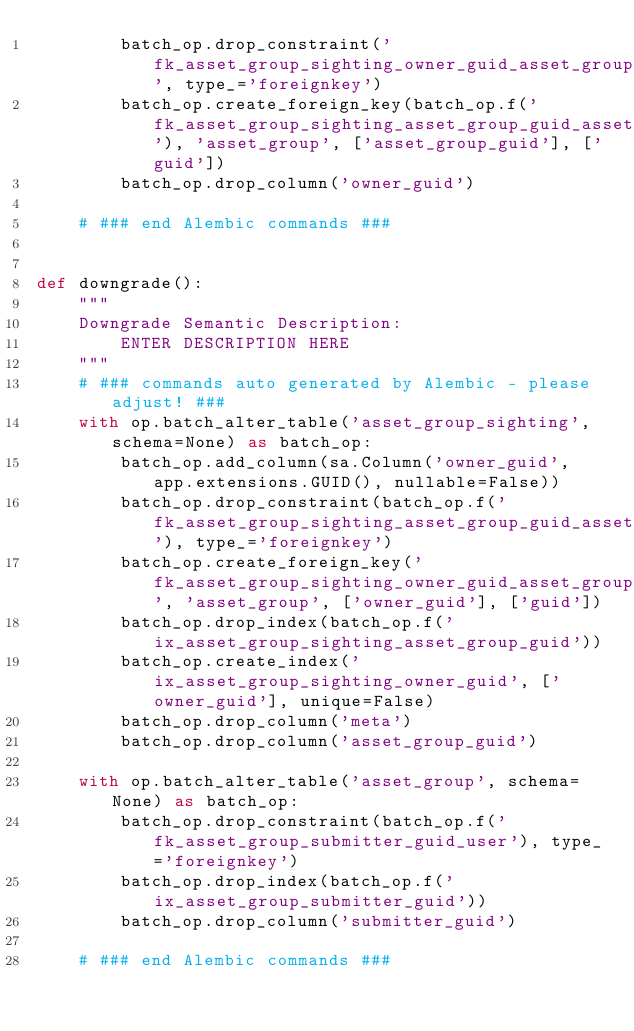<code> <loc_0><loc_0><loc_500><loc_500><_Python_>        batch_op.drop_constraint('fk_asset_group_sighting_owner_guid_asset_group', type_='foreignkey')
        batch_op.create_foreign_key(batch_op.f('fk_asset_group_sighting_asset_group_guid_asset_group'), 'asset_group', ['asset_group_guid'], ['guid'])
        batch_op.drop_column('owner_guid')

    # ### end Alembic commands ###


def downgrade():
    """
    Downgrade Semantic Description:
        ENTER DESCRIPTION HERE
    """
    # ### commands auto generated by Alembic - please adjust! ###
    with op.batch_alter_table('asset_group_sighting', schema=None) as batch_op:
        batch_op.add_column(sa.Column('owner_guid', app.extensions.GUID(), nullable=False))
        batch_op.drop_constraint(batch_op.f('fk_asset_group_sighting_asset_group_guid_asset_group'), type_='foreignkey')
        batch_op.create_foreign_key('fk_asset_group_sighting_owner_guid_asset_group', 'asset_group', ['owner_guid'], ['guid'])
        batch_op.drop_index(batch_op.f('ix_asset_group_sighting_asset_group_guid'))
        batch_op.create_index('ix_asset_group_sighting_owner_guid', ['owner_guid'], unique=False)
        batch_op.drop_column('meta')
        batch_op.drop_column('asset_group_guid')

    with op.batch_alter_table('asset_group', schema=None) as batch_op:
        batch_op.drop_constraint(batch_op.f('fk_asset_group_submitter_guid_user'), type_='foreignkey')
        batch_op.drop_index(batch_op.f('ix_asset_group_submitter_guid'))
        batch_op.drop_column('submitter_guid')

    # ### end Alembic commands ###
</code> 